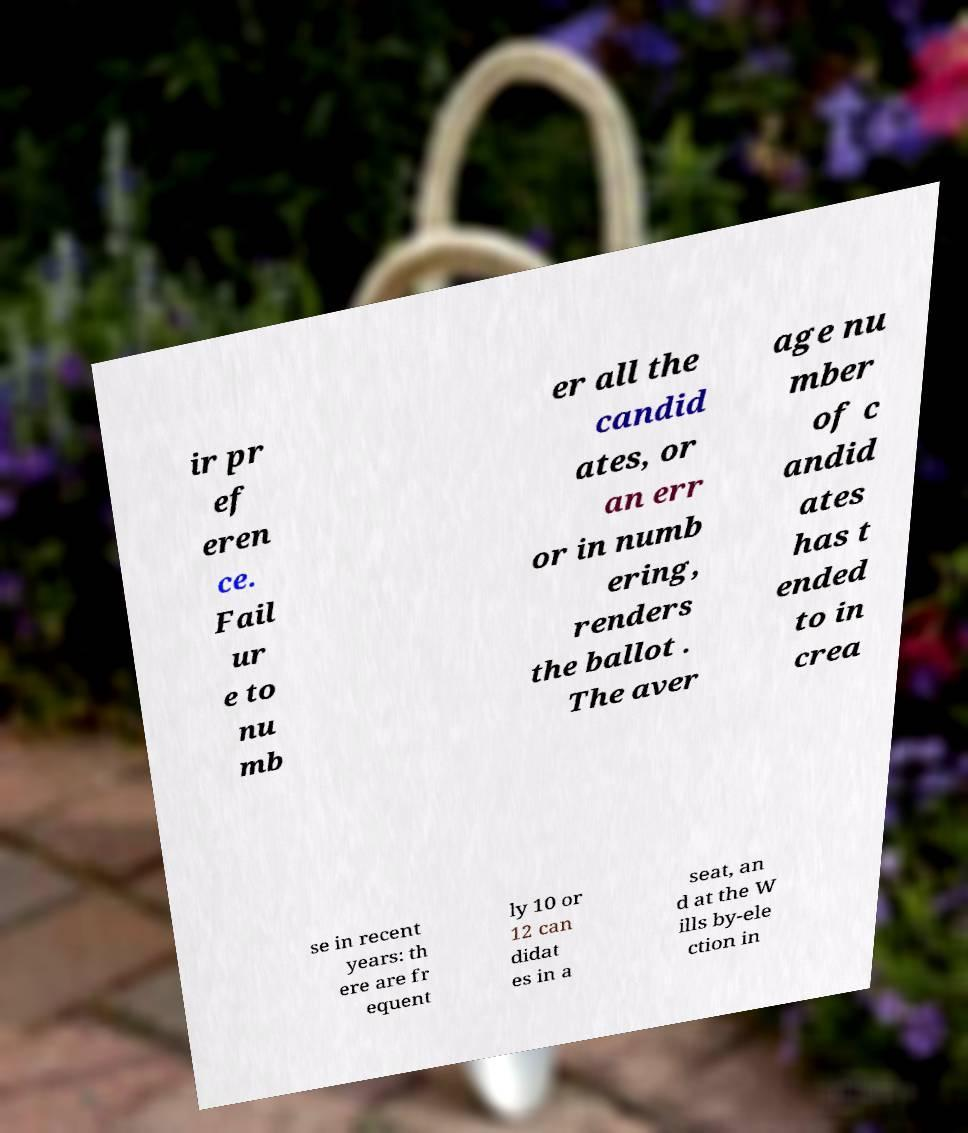Can you accurately transcribe the text from the provided image for me? ir pr ef eren ce. Fail ur e to nu mb er all the candid ates, or an err or in numb ering, renders the ballot . The aver age nu mber of c andid ates has t ended to in crea se in recent years: th ere are fr equent ly 10 or 12 can didat es in a seat, an d at the W ills by-ele ction in 